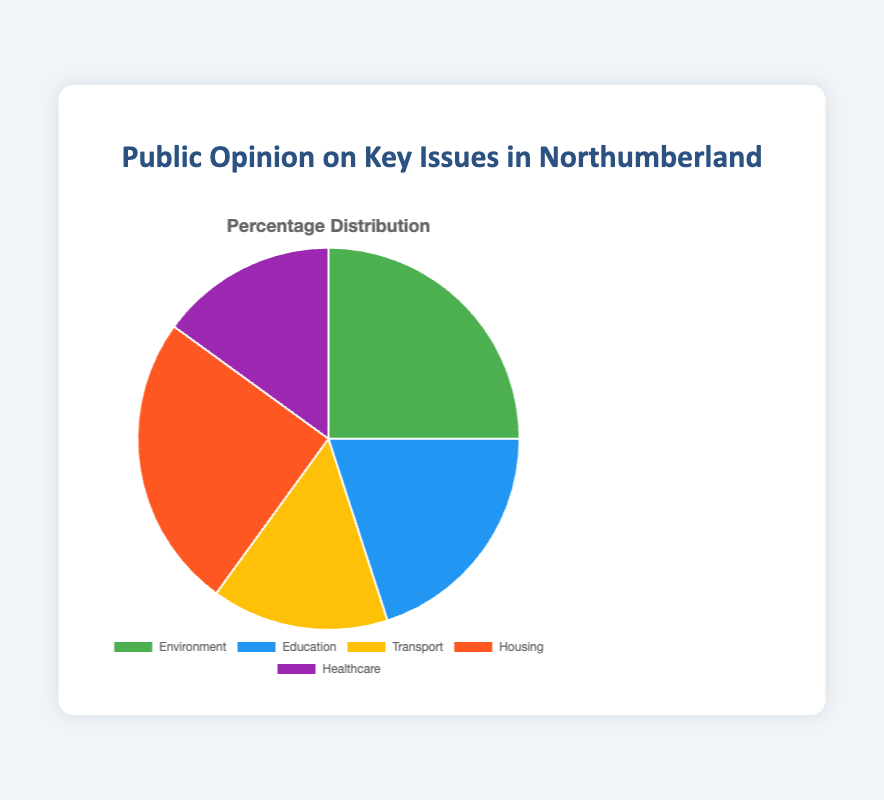What percentage of people are concerned about Environment and Housing combined? The percentage for Environment is 25%, and for Housing also 25%. Adding them together, we get 25% + 25% = 50%.
Answer: 50% Which issue has the same level of concern as Healthcare? Both Healthcare and Transport have 15% of concern.
Answer: Transport Which two issues have the highest concern? Looking at the chart, Environment and Housing both have the highest concern at 25%.
Answer: Environment and Housing How many percentage points higher is the concern for Environment compared to Transport? The percentage for Environment is 25%, and for Transport, it is 15%. The difference is 25% - 15% = 10%.
Answer: 10% Subtract the percentage for Education from the percentage for Housing. What is the result? Housing has 25%, and Education has 20%. Subtracting, we get 25% - 20% = 5%.
Answer: 5% Compare the levels of concern for Transport and Housing. Which one is higher and by how much? Transport has 15% concern and Housing has 25%. Housing is higher by 25% - 15% = 10%.
Answer: Housing, 10% What is the average percentage of concern across all issues? Adding all percentages: 25% (Environment) + 20% (Education) + 15% (Transport) + 25% (Housing) + 15% (Healthcare) = 100%. Dividing by 5 (the number of issues), 100% / 5 = 20%.
Answer: 20% If we combine the categories with less than 20% concern, what is the total? The categories with less than 20% are Transport (15%) and Healthcare (15%). Adding them gives 15% + 15% = 30%.
Answer: 30% Between Environment, Education, and Housing, which one has the lowest concern and what is the difference between it and the highest concern? Among Environment (25%), Education (20%), and Housing (25%), Education has the lowest concern. The difference between the highest (25%) and lowest (20%) is 25% - 20% = 5%.
Answer: Education, 5% 